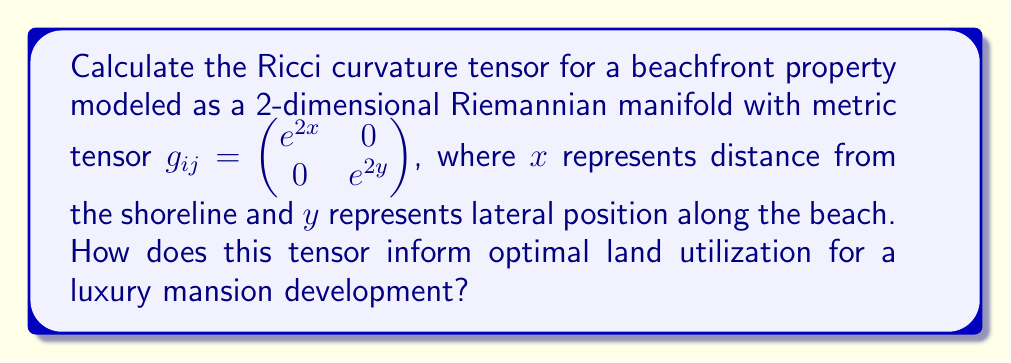Can you solve this math problem? To calculate the Ricci curvature tensor, we'll follow these steps:

1) First, calculate the Christoffel symbols:
   $$\Gamma^k_{ij} = \frac{1}{2}g^{kl}(\partial_i g_{jl} + \partial_j g_{il} - \partial_l g_{ij})$$

   The non-zero Christoffel symbols are:
   $$\Gamma^1_{11} = 1, \Gamma^2_{22} = 1$$

2) Next, calculate the Riemann curvature tensor:
   $$R^l_{ijk} = \partial_i \Gamma^l_{jk} - \partial_j \Gamma^l_{ik} + \Gamma^m_{jk}\Gamma^l_{im} - \Gamma^m_{ik}\Gamma^l_{jm}$$

   The non-zero components are:
   $$R^1_{212} = -e^{2(y-x)}, R^2_{121} = -e^{2(x-y)}$$

3) Now, calculate the Ricci tensor:
   $$R_{ij} = R^k_{ikj}$$

   The components are:
   $$R_{11} = -1, R_{22} = -1$$

4) Therefore, the Ricci curvature tensor is:
   $$R_{ij} = \begin{pmatrix} -1 & 0 \\ 0 & -1 \end{pmatrix}$$

This tensor informs optimal land utilization as follows:

- The negative curvature indicates that the space is hyperbolic, suggesting that the perceived area increases faster than in flat space as you move away from a point.
- This implies that building closer to the shoreline (small x) maximizes the perceived spaciousness of the property.
- The uniform curvature in both directions suggests that lateral position (y) doesn't affect perceived space, so focus should be on proximity to the shore.
- For a luxury mansion, this suggests designing a wide beachfront facade to capitalize on the increased perceived space near the shoreline.
Answer: $R_{ij} = \begin{pmatrix} -1 & 0 \\ 0 & -1 \end{pmatrix}$; Build wide and close to shore. 